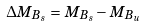<formula> <loc_0><loc_0><loc_500><loc_500>\Delta M _ { B _ { s } } = M _ { B _ { s } } - M _ { B _ { u } }</formula> 